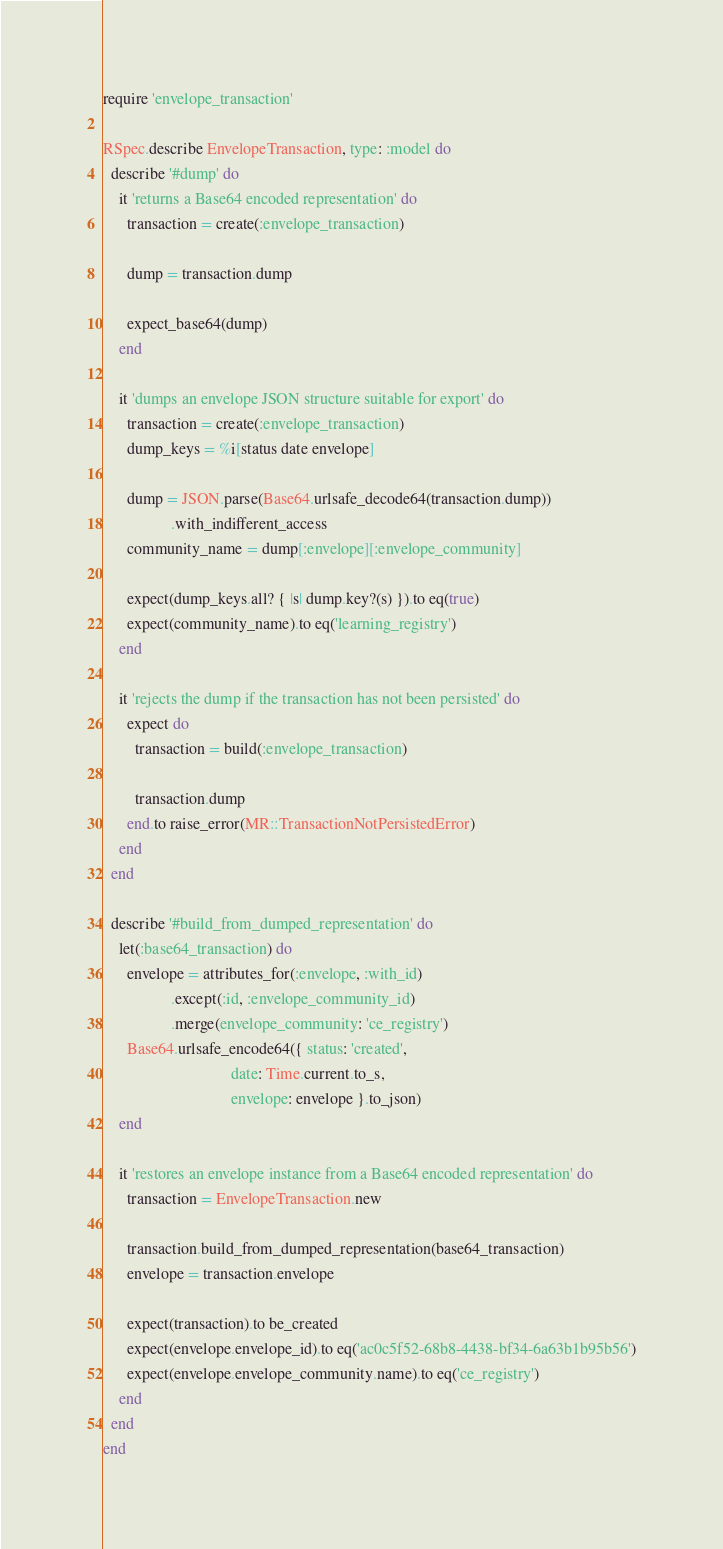Convert code to text. <code><loc_0><loc_0><loc_500><loc_500><_Ruby_>require 'envelope_transaction'

RSpec.describe EnvelopeTransaction, type: :model do
  describe '#dump' do
    it 'returns a Base64 encoded representation' do
      transaction = create(:envelope_transaction)

      dump = transaction.dump

      expect_base64(dump)
    end

    it 'dumps an envelope JSON structure suitable for export' do
      transaction = create(:envelope_transaction)
      dump_keys = %i[status date envelope]

      dump = JSON.parse(Base64.urlsafe_decode64(transaction.dump))
                 .with_indifferent_access
      community_name = dump[:envelope][:envelope_community]

      expect(dump_keys.all? { |s| dump.key?(s) }).to eq(true)
      expect(community_name).to eq('learning_registry')
    end

    it 'rejects the dump if the transaction has not been persisted' do
      expect do
        transaction = build(:envelope_transaction)

        transaction.dump
      end.to raise_error(MR::TransactionNotPersistedError)
    end
  end

  describe '#build_from_dumped_representation' do
    let(:base64_transaction) do
      envelope = attributes_for(:envelope, :with_id)
                 .except(:id, :envelope_community_id)
                 .merge(envelope_community: 'ce_registry')
      Base64.urlsafe_encode64({ status: 'created',
                                date: Time.current.to_s,
                                envelope: envelope }.to_json)
    end

    it 'restores an envelope instance from a Base64 encoded representation' do
      transaction = EnvelopeTransaction.new

      transaction.build_from_dumped_representation(base64_transaction)
      envelope = transaction.envelope

      expect(transaction).to be_created
      expect(envelope.envelope_id).to eq('ac0c5f52-68b8-4438-bf34-6a63b1b95b56')
      expect(envelope.envelope_community.name).to eq('ce_registry')
    end
  end
end
</code> 